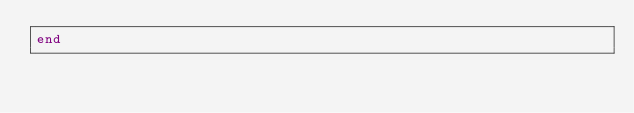<code> <loc_0><loc_0><loc_500><loc_500><_Ruby_>end
</code> 